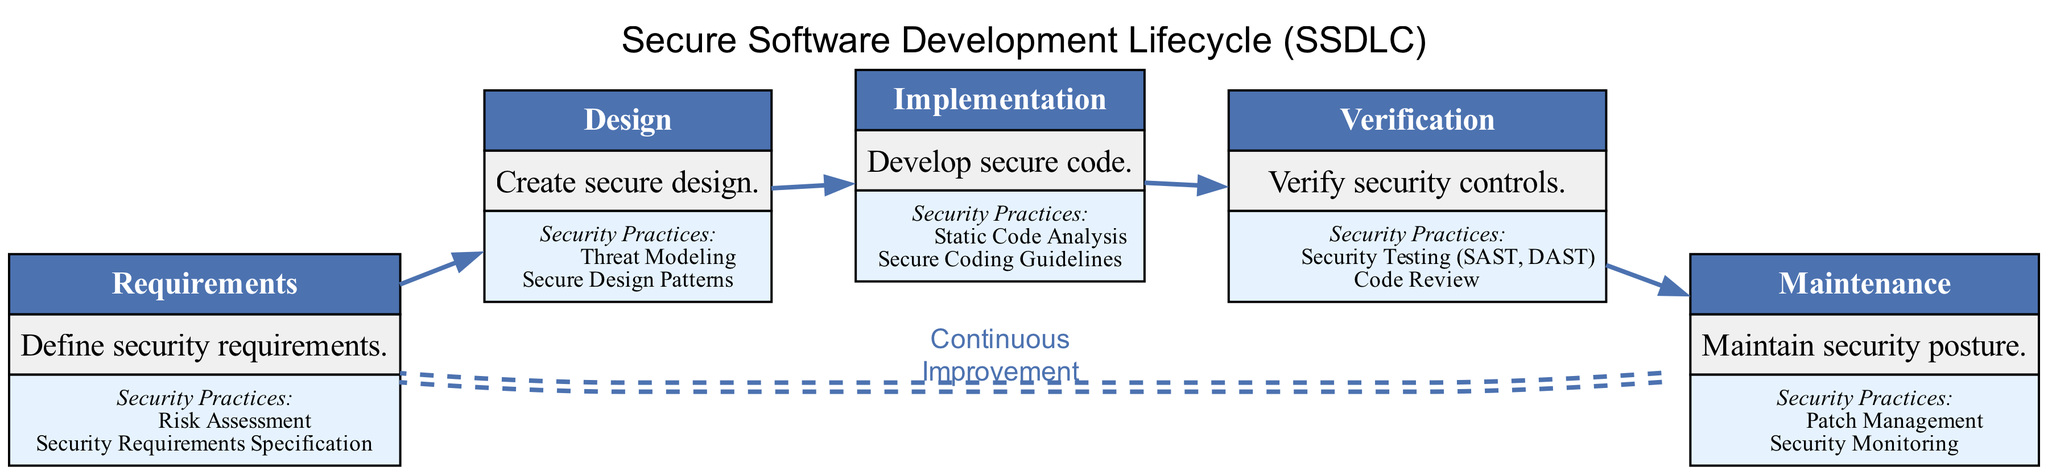What are the two security practices listed under the Requirements phase? The Requirements phase lists "Risk Assessment" and "Security Requirements Specification" as its security practices, as seen in the third row of the node corresponding to this phase.
Answer: Risk Assessment, Security Requirements Specification Which phase emphasizes Threat Modeling as a security practice? The design phase is where "Threat Modeling" is highlighted as a key security practice, indicated in the security practices section of the design phase node.
Answer: Design What is the last phase in the Secure Software Development Lifecycle? The last phase in the diagram is "Maintenance," as evident from the bottom node in the flow of the diagram.
Answer: Maintenance How many security practices are identified in the Verification phase? In the Verification phase, two security practices are identified: "Security Testing (SAST, DAST)" and "Code Review," which can be counted from the listed practices in the corresponding node.
Answer: Two What is the purpose of the Continuous Improvement label in the diagram? The Continuous Improvement label connects the last phase back to the first phase, indicating the iterative nature of the SSDLC process, reinforcing that security practices should be continuously refined throughout the life cycle.
Answer: Continuous Improvement Which phase follows the Implementation phase? The phase that follows Implementation is Verification, as indicated by the connecting edge from the Implementation node to the Verification node.
Answer: Verification What are the two security practices mentioned in the Maintenance phase? The Maintenance phase mentions "Patch Management" and "Security Monitoring" as its security practices, as listed in the corresponding node of the diagram.
Answer: Patch Management, Security Monitoring What type of diagram is used to represent the Secure Software Development Lifecycle? The diagram represents a directed graph, which facilitates the flow of phases in a structured manner, linking the processes of SSDLC visually.
Answer: Directed graph 